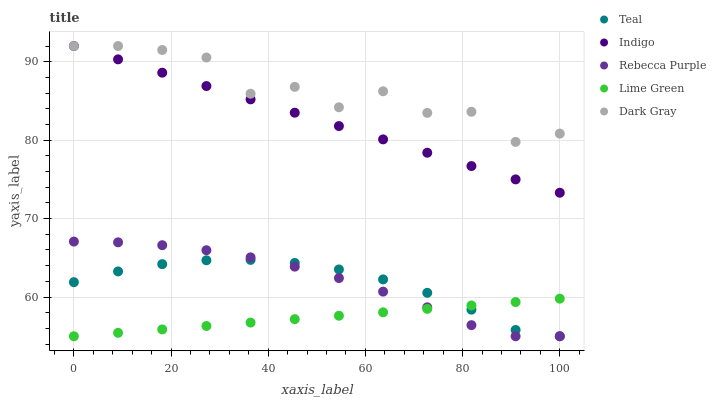Does Lime Green have the minimum area under the curve?
Answer yes or no. Yes. Does Dark Gray have the maximum area under the curve?
Answer yes or no. Yes. Does Indigo have the minimum area under the curve?
Answer yes or no. No. Does Indigo have the maximum area under the curve?
Answer yes or no. No. Is Lime Green the smoothest?
Answer yes or no. Yes. Is Dark Gray the roughest?
Answer yes or no. Yes. Is Indigo the smoothest?
Answer yes or no. No. Is Indigo the roughest?
Answer yes or no. No. Does Lime Green have the lowest value?
Answer yes or no. Yes. Does Indigo have the lowest value?
Answer yes or no. No. Does Indigo have the highest value?
Answer yes or no. Yes. Does Lime Green have the highest value?
Answer yes or no. No. Is Rebecca Purple less than Indigo?
Answer yes or no. Yes. Is Dark Gray greater than Rebecca Purple?
Answer yes or no. Yes. Does Lime Green intersect Rebecca Purple?
Answer yes or no. Yes. Is Lime Green less than Rebecca Purple?
Answer yes or no. No. Is Lime Green greater than Rebecca Purple?
Answer yes or no. No. Does Rebecca Purple intersect Indigo?
Answer yes or no. No. 